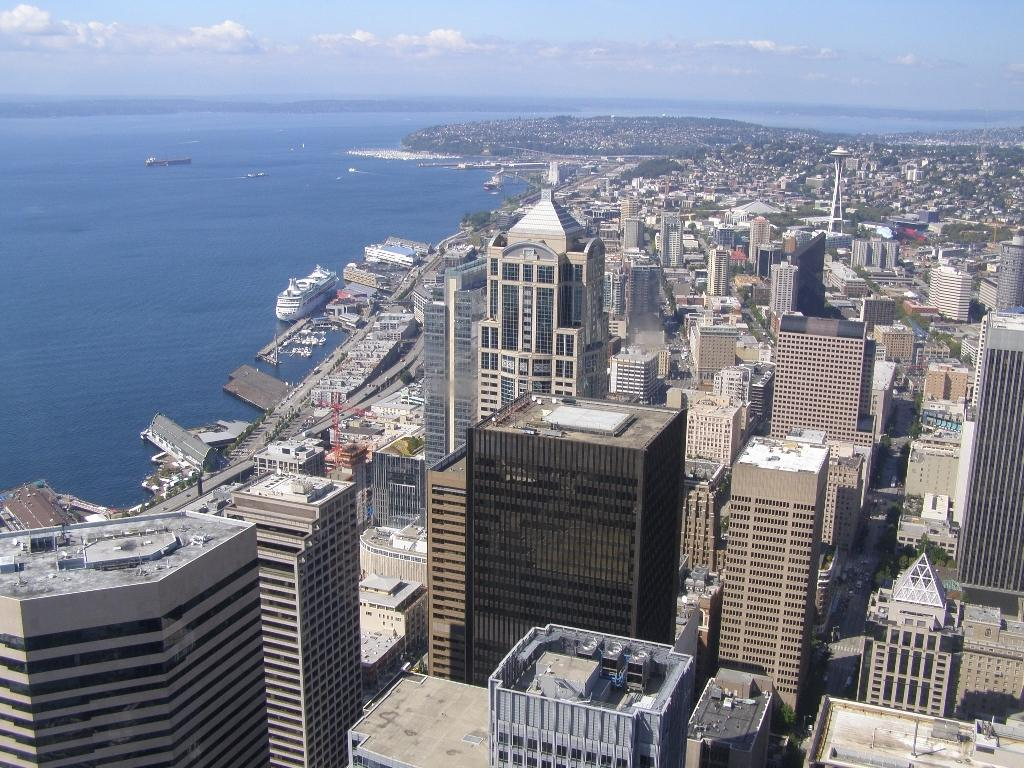What type of structures can be seen in the image? There are buildings in the image. What other natural elements are present in the image? There are trees in the image. What object can be seen standing upright in the image? There is a pole in the image. What is on the water in the image? There are ships on the water in the image. What part of the natural environment is visible in the background of the image? There is sky visible in the background of the image. What can be observed in the sky? There are clouds in the sky. What is the distance between the buildings and the afterthought in the image? There is no afterthought present in the image, so it is not possible to determine the distance between it and the buildings. What is the zinc content of the ships in the image? There is no information about the zinc content of the ships in the image, as it does not provide any details about their composition. 